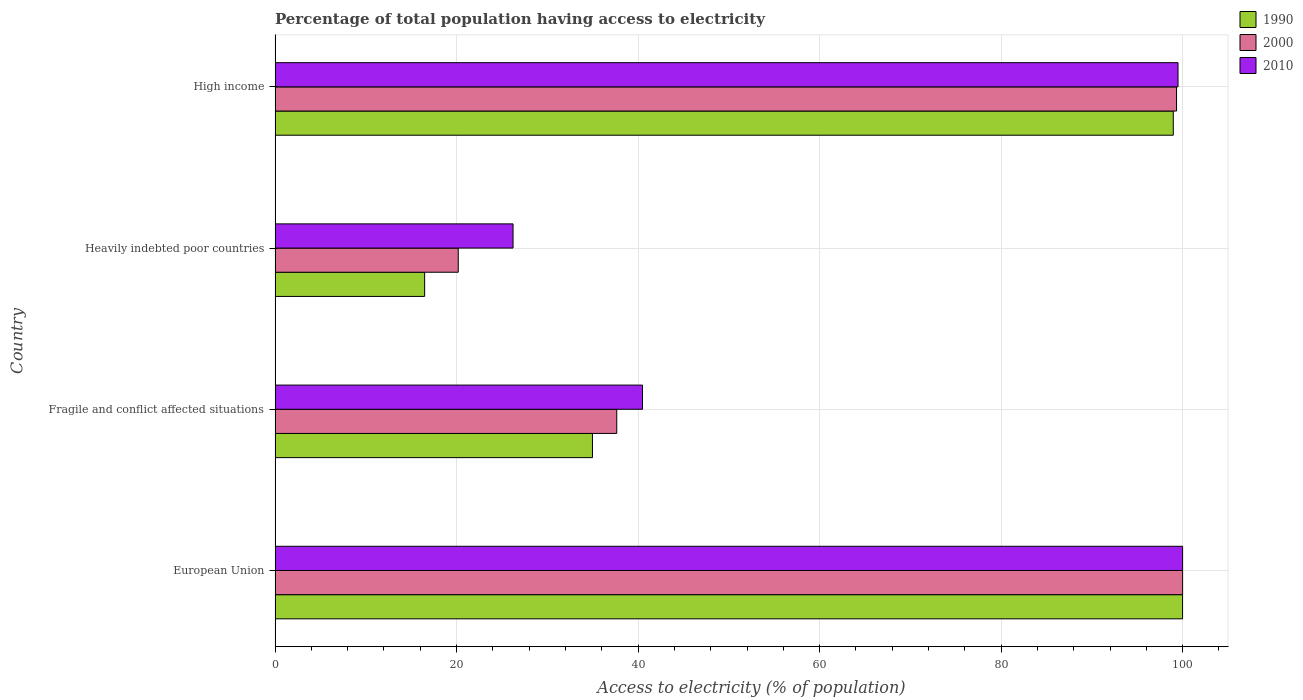How many different coloured bars are there?
Your answer should be compact. 3. Are the number of bars per tick equal to the number of legend labels?
Offer a very short reply. Yes. What is the label of the 3rd group of bars from the top?
Your answer should be compact. Fragile and conflict affected situations. In how many cases, is the number of bars for a given country not equal to the number of legend labels?
Offer a very short reply. 0. What is the percentage of population that have access to electricity in 2010 in Fragile and conflict affected situations?
Your answer should be compact. 40.49. Across all countries, what is the minimum percentage of population that have access to electricity in 2010?
Make the answer very short. 26.22. In which country was the percentage of population that have access to electricity in 1990 maximum?
Provide a succinct answer. European Union. In which country was the percentage of population that have access to electricity in 1990 minimum?
Offer a terse response. Heavily indebted poor countries. What is the total percentage of population that have access to electricity in 1990 in the graph?
Your answer should be compact. 250.42. What is the difference between the percentage of population that have access to electricity in 2000 in European Union and that in High income?
Make the answer very short. 0.67. What is the difference between the percentage of population that have access to electricity in 2000 in High income and the percentage of population that have access to electricity in 1990 in Fragile and conflict affected situations?
Keep it short and to the point. 64.36. What is the average percentage of population that have access to electricity in 2000 per country?
Provide a short and direct response. 64.29. What is the difference between the percentage of population that have access to electricity in 2010 and percentage of population that have access to electricity in 2000 in European Union?
Ensure brevity in your answer.  0. What is the ratio of the percentage of population that have access to electricity in 2010 in Fragile and conflict affected situations to that in Heavily indebted poor countries?
Offer a very short reply. 1.54. Is the percentage of population that have access to electricity in 2000 in European Union less than that in High income?
Keep it short and to the point. No. Is the difference between the percentage of population that have access to electricity in 2010 in European Union and High income greater than the difference between the percentage of population that have access to electricity in 2000 in European Union and High income?
Keep it short and to the point. No. What is the difference between the highest and the second highest percentage of population that have access to electricity in 2010?
Offer a very short reply. 0.51. What is the difference between the highest and the lowest percentage of population that have access to electricity in 2010?
Offer a very short reply. 73.78. Is the sum of the percentage of population that have access to electricity in 2000 in Fragile and conflict affected situations and Heavily indebted poor countries greater than the maximum percentage of population that have access to electricity in 2010 across all countries?
Make the answer very short. No. Is it the case that in every country, the sum of the percentage of population that have access to electricity in 2010 and percentage of population that have access to electricity in 2000 is greater than the percentage of population that have access to electricity in 1990?
Offer a very short reply. Yes. Are all the bars in the graph horizontal?
Your response must be concise. Yes. How many countries are there in the graph?
Provide a succinct answer. 4. How many legend labels are there?
Keep it short and to the point. 3. How are the legend labels stacked?
Your response must be concise. Vertical. What is the title of the graph?
Ensure brevity in your answer.  Percentage of total population having access to electricity. Does "1994" appear as one of the legend labels in the graph?
Your answer should be very brief. No. What is the label or title of the X-axis?
Make the answer very short. Access to electricity (% of population). What is the Access to electricity (% of population) in 1990 in European Union?
Ensure brevity in your answer.  99.99. What is the Access to electricity (% of population) in 2010 in European Union?
Offer a very short reply. 100. What is the Access to electricity (% of population) of 1990 in Fragile and conflict affected situations?
Your answer should be very brief. 34.97. What is the Access to electricity (% of population) of 2000 in Fragile and conflict affected situations?
Your answer should be compact. 37.65. What is the Access to electricity (% of population) in 2010 in Fragile and conflict affected situations?
Your answer should be compact. 40.49. What is the Access to electricity (% of population) of 1990 in Heavily indebted poor countries?
Offer a very short reply. 16.48. What is the Access to electricity (% of population) of 2000 in Heavily indebted poor countries?
Offer a terse response. 20.18. What is the Access to electricity (% of population) in 2010 in Heavily indebted poor countries?
Give a very brief answer. 26.22. What is the Access to electricity (% of population) in 1990 in High income?
Give a very brief answer. 98.97. What is the Access to electricity (% of population) in 2000 in High income?
Keep it short and to the point. 99.33. What is the Access to electricity (% of population) in 2010 in High income?
Keep it short and to the point. 99.49. Across all countries, what is the maximum Access to electricity (% of population) of 1990?
Give a very brief answer. 99.99. Across all countries, what is the maximum Access to electricity (% of population) of 2000?
Your answer should be compact. 100. Across all countries, what is the maximum Access to electricity (% of population) in 2010?
Your answer should be compact. 100. Across all countries, what is the minimum Access to electricity (% of population) in 1990?
Offer a very short reply. 16.48. Across all countries, what is the minimum Access to electricity (% of population) of 2000?
Provide a succinct answer. 20.18. Across all countries, what is the minimum Access to electricity (% of population) of 2010?
Your answer should be compact. 26.22. What is the total Access to electricity (% of population) in 1990 in the graph?
Give a very brief answer. 250.42. What is the total Access to electricity (% of population) of 2000 in the graph?
Ensure brevity in your answer.  257.16. What is the total Access to electricity (% of population) of 2010 in the graph?
Your answer should be very brief. 266.2. What is the difference between the Access to electricity (% of population) of 1990 in European Union and that in Fragile and conflict affected situations?
Offer a very short reply. 65.02. What is the difference between the Access to electricity (% of population) in 2000 in European Union and that in Fragile and conflict affected situations?
Your answer should be very brief. 62.35. What is the difference between the Access to electricity (% of population) of 2010 in European Union and that in Fragile and conflict affected situations?
Make the answer very short. 59.51. What is the difference between the Access to electricity (% of population) in 1990 in European Union and that in Heavily indebted poor countries?
Make the answer very short. 83.51. What is the difference between the Access to electricity (% of population) in 2000 in European Union and that in Heavily indebted poor countries?
Provide a succinct answer. 79.82. What is the difference between the Access to electricity (% of population) of 2010 in European Union and that in Heavily indebted poor countries?
Offer a terse response. 73.78. What is the difference between the Access to electricity (% of population) of 1990 in European Union and that in High income?
Keep it short and to the point. 1.02. What is the difference between the Access to electricity (% of population) in 2000 in European Union and that in High income?
Your response must be concise. 0.67. What is the difference between the Access to electricity (% of population) in 2010 in European Union and that in High income?
Offer a very short reply. 0.51. What is the difference between the Access to electricity (% of population) of 1990 in Fragile and conflict affected situations and that in Heavily indebted poor countries?
Provide a short and direct response. 18.49. What is the difference between the Access to electricity (% of population) of 2000 in Fragile and conflict affected situations and that in Heavily indebted poor countries?
Offer a terse response. 17.46. What is the difference between the Access to electricity (% of population) of 2010 in Fragile and conflict affected situations and that in Heavily indebted poor countries?
Your answer should be compact. 14.27. What is the difference between the Access to electricity (% of population) in 1990 in Fragile and conflict affected situations and that in High income?
Your response must be concise. -64. What is the difference between the Access to electricity (% of population) of 2000 in Fragile and conflict affected situations and that in High income?
Offer a terse response. -61.68. What is the difference between the Access to electricity (% of population) of 2010 in Fragile and conflict affected situations and that in High income?
Your answer should be very brief. -59.01. What is the difference between the Access to electricity (% of population) in 1990 in Heavily indebted poor countries and that in High income?
Make the answer very short. -82.49. What is the difference between the Access to electricity (% of population) in 2000 in Heavily indebted poor countries and that in High income?
Offer a very short reply. -79.15. What is the difference between the Access to electricity (% of population) in 2010 in Heavily indebted poor countries and that in High income?
Your answer should be very brief. -73.27. What is the difference between the Access to electricity (% of population) of 1990 in European Union and the Access to electricity (% of population) of 2000 in Fragile and conflict affected situations?
Give a very brief answer. 62.35. What is the difference between the Access to electricity (% of population) of 1990 in European Union and the Access to electricity (% of population) of 2010 in Fragile and conflict affected situations?
Your response must be concise. 59.51. What is the difference between the Access to electricity (% of population) of 2000 in European Union and the Access to electricity (% of population) of 2010 in Fragile and conflict affected situations?
Your answer should be compact. 59.51. What is the difference between the Access to electricity (% of population) in 1990 in European Union and the Access to electricity (% of population) in 2000 in Heavily indebted poor countries?
Your answer should be compact. 79.81. What is the difference between the Access to electricity (% of population) of 1990 in European Union and the Access to electricity (% of population) of 2010 in Heavily indebted poor countries?
Keep it short and to the point. 73.77. What is the difference between the Access to electricity (% of population) of 2000 in European Union and the Access to electricity (% of population) of 2010 in Heavily indebted poor countries?
Offer a very short reply. 73.78. What is the difference between the Access to electricity (% of population) in 1990 in European Union and the Access to electricity (% of population) in 2000 in High income?
Provide a short and direct response. 0.66. What is the difference between the Access to electricity (% of population) of 1990 in European Union and the Access to electricity (% of population) of 2010 in High income?
Offer a very short reply. 0.5. What is the difference between the Access to electricity (% of population) in 2000 in European Union and the Access to electricity (% of population) in 2010 in High income?
Ensure brevity in your answer.  0.51. What is the difference between the Access to electricity (% of population) of 1990 in Fragile and conflict affected situations and the Access to electricity (% of population) of 2000 in Heavily indebted poor countries?
Provide a succinct answer. 14.79. What is the difference between the Access to electricity (% of population) of 1990 in Fragile and conflict affected situations and the Access to electricity (% of population) of 2010 in Heavily indebted poor countries?
Your answer should be very brief. 8.75. What is the difference between the Access to electricity (% of population) in 2000 in Fragile and conflict affected situations and the Access to electricity (% of population) in 2010 in Heavily indebted poor countries?
Your answer should be compact. 11.43. What is the difference between the Access to electricity (% of population) of 1990 in Fragile and conflict affected situations and the Access to electricity (% of population) of 2000 in High income?
Your response must be concise. -64.36. What is the difference between the Access to electricity (% of population) in 1990 in Fragile and conflict affected situations and the Access to electricity (% of population) in 2010 in High income?
Give a very brief answer. -64.52. What is the difference between the Access to electricity (% of population) of 2000 in Fragile and conflict affected situations and the Access to electricity (% of population) of 2010 in High income?
Your answer should be compact. -61.85. What is the difference between the Access to electricity (% of population) of 1990 in Heavily indebted poor countries and the Access to electricity (% of population) of 2000 in High income?
Provide a succinct answer. -82.85. What is the difference between the Access to electricity (% of population) of 1990 in Heavily indebted poor countries and the Access to electricity (% of population) of 2010 in High income?
Provide a succinct answer. -83.01. What is the difference between the Access to electricity (% of population) of 2000 in Heavily indebted poor countries and the Access to electricity (% of population) of 2010 in High income?
Give a very brief answer. -79.31. What is the average Access to electricity (% of population) in 1990 per country?
Your answer should be very brief. 62.6. What is the average Access to electricity (% of population) in 2000 per country?
Keep it short and to the point. 64.29. What is the average Access to electricity (% of population) of 2010 per country?
Ensure brevity in your answer.  66.55. What is the difference between the Access to electricity (% of population) in 1990 and Access to electricity (% of population) in 2000 in European Union?
Provide a short and direct response. -0.01. What is the difference between the Access to electricity (% of population) in 1990 and Access to electricity (% of population) in 2010 in European Union?
Give a very brief answer. -0.01. What is the difference between the Access to electricity (% of population) in 2000 and Access to electricity (% of population) in 2010 in European Union?
Ensure brevity in your answer.  0. What is the difference between the Access to electricity (% of population) in 1990 and Access to electricity (% of population) in 2000 in Fragile and conflict affected situations?
Ensure brevity in your answer.  -2.68. What is the difference between the Access to electricity (% of population) in 1990 and Access to electricity (% of population) in 2010 in Fragile and conflict affected situations?
Provide a short and direct response. -5.51. What is the difference between the Access to electricity (% of population) of 2000 and Access to electricity (% of population) of 2010 in Fragile and conflict affected situations?
Keep it short and to the point. -2.84. What is the difference between the Access to electricity (% of population) in 1990 and Access to electricity (% of population) in 2000 in Heavily indebted poor countries?
Offer a very short reply. -3.7. What is the difference between the Access to electricity (% of population) in 1990 and Access to electricity (% of population) in 2010 in Heavily indebted poor countries?
Your answer should be compact. -9.74. What is the difference between the Access to electricity (% of population) of 2000 and Access to electricity (% of population) of 2010 in Heavily indebted poor countries?
Provide a succinct answer. -6.04. What is the difference between the Access to electricity (% of population) of 1990 and Access to electricity (% of population) of 2000 in High income?
Give a very brief answer. -0.36. What is the difference between the Access to electricity (% of population) of 1990 and Access to electricity (% of population) of 2010 in High income?
Keep it short and to the point. -0.52. What is the difference between the Access to electricity (% of population) in 2000 and Access to electricity (% of population) in 2010 in High income?
Offer a terse response. -0.16. What is the ratio of the Access to electricity (% of population) of 1990 in European Union to that in Fragile and conflict affected situations?
Offer a terse response. 2.86. What is the ratio of the Access to electricity (% of population) in 2000 in European Union to that in Fragile and conflict affected situations?
Offer a terse response. 2.66. What is the ratio of the Access to electricity (% of population) in 2010 in European Union to that in Fragile and conflict affected situations?
Your response must be concise. 2.47. What is the ratio of the Access to electricity (% of population) in 1990 in European Union to that in Heavily indebted poor countries?
Your answer should be very brief. 6.07. What is the ratio of the Access to electricity (% of population) in 2000 in European Union to that in Heavily indebted poor countries?
Make the answer very short. 4.95. What is the ratio of the Access to electricity (% of population) of 2010 in European Union to that in Heavily indebted poor countries?
Provide a short and direct response. 3.81. What is the ratio of the Access to electricity (% of population) of 1990 in European Union to that in High income?
Offer a very short reply. 1.01. What is the ratio of the Access to electricity (% of population) of 1990 in Fragile and conflict affected situations to that in Heavily indebted poor countries?
Offer a terse response. 2.12. What is the ratio of the Access to electricity (% of population) in 2000 in Fragile and conflict affected situations to that in Heavily indebted poor countries?
Make the answer very short. 1.87. What is the ratio of the Access to electricity (% of population) in 2010 in Fragile and conflict affected situations to that in Heavily indebted poor countries?
Keep it short and to the point. 1.54. What is the ratio of the Access to electricity (% of population) in 1990 in Fragile and conflict affected situations to that in High income?
Provide a short and direct response. 0.35. What is the ratio of the Access to electricity (% of population) of 2000 in Fragile and conflict affected situations to that in High income?
Your response must be concise. 0.38. What is the ratio of the Access to electricity (% of population) in 2010 in Fragile and conflict affected situations to that in High income?
Your answer should be very brief. 0.41. What is the ratio of the Access to electricity (% of population) of 1990 in Heavily indebted poor countries to that in High income?
Make the answer very short. 0.17. What is the ratio of the Access to electricity (% of population) in 2000 in Heavily indebted poor countries to that in High income?
Make the answer very short. 0.2. What is the ratio of the Access to electricity (% of population) of 2010 in Heavily indebted poor countries to that in High income?
Your response must be concise. 0.26. What is the difference between the highest and the second highest Access to electricity (% of population) in 1990?
Ensure brevity in your answer.  1.02. What is the difference between the highest and the second highest Access to electricity (% of population) in 2000?
Your answer should be very brief. 0.67. What is the difference between the highest and the second highest Access to electricity (% of population) in 2010?
Your response must be concise. 0.51. What is the difference between the highest and the lowest Access to electricity (% of population) of 1990?
Offer a very short reply. 83.51. What is the difference between the highest and the lowest Access to electricity (% of population) of 2000?
Your answer should be very brief. 79.82. What is the difference between the highest and the lowest Access to electricity (% of population) of 2010?
Give a very brief answer. 73.78. 